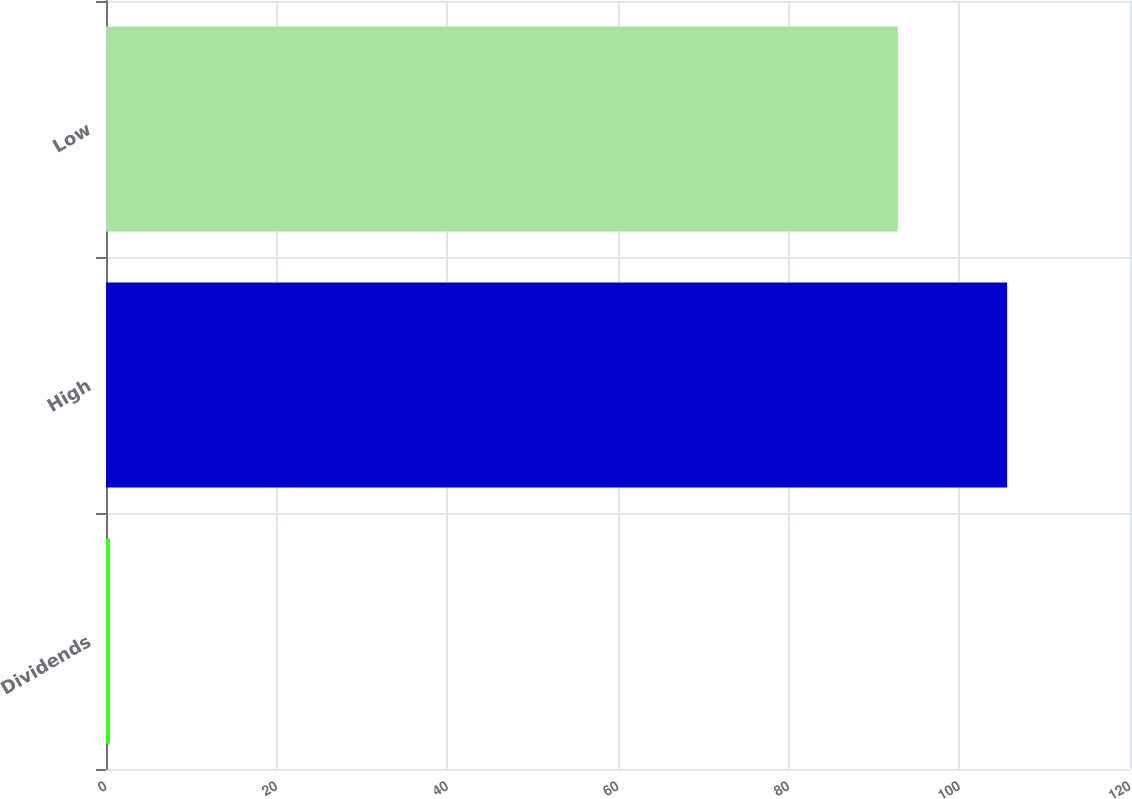<chart> <loc_0><loc_0><loc_500><loc_500><bar_chart><fcel>Dividends<fcel>High<fcel>Low<nl><fcel>0.47<fcel>105.6<fcel>92.8<nl></chart> 